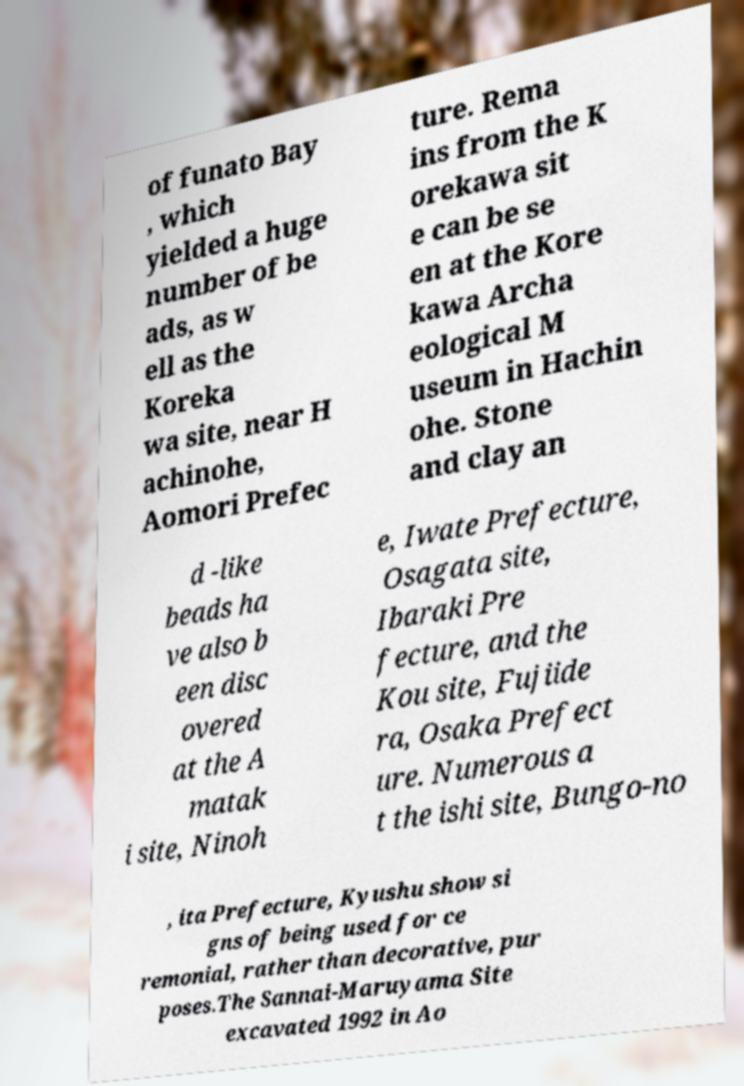There's text embedded in this image that I need extracted. Can you transcribe it verbatim? of funato Bay , which yielded a huge number of be ads, as w ell as the Koreka wa site, near H achinohe, Aomori Prefec ture. Rema ins from the K orekawa sit e can be se en at the Kore kawa Archa eological M useum in Hachin ohe. Stone and clay an d -like beads ha ve also b een disc overed at the A matak i site, Ninoh e, Iwate Prefecture, Osagata site, Ibaraki Pre fecture, and the Kou site, Fujiide ra, Osaka Prefect ure. Numerous a t the ishi site, Bungo-no , ita Prefecture, Kyushu show si gns of being used for ce remonial, rather than decorative, pur poses.The Sannai-Maruyama Site excavated 1992 in Ao 